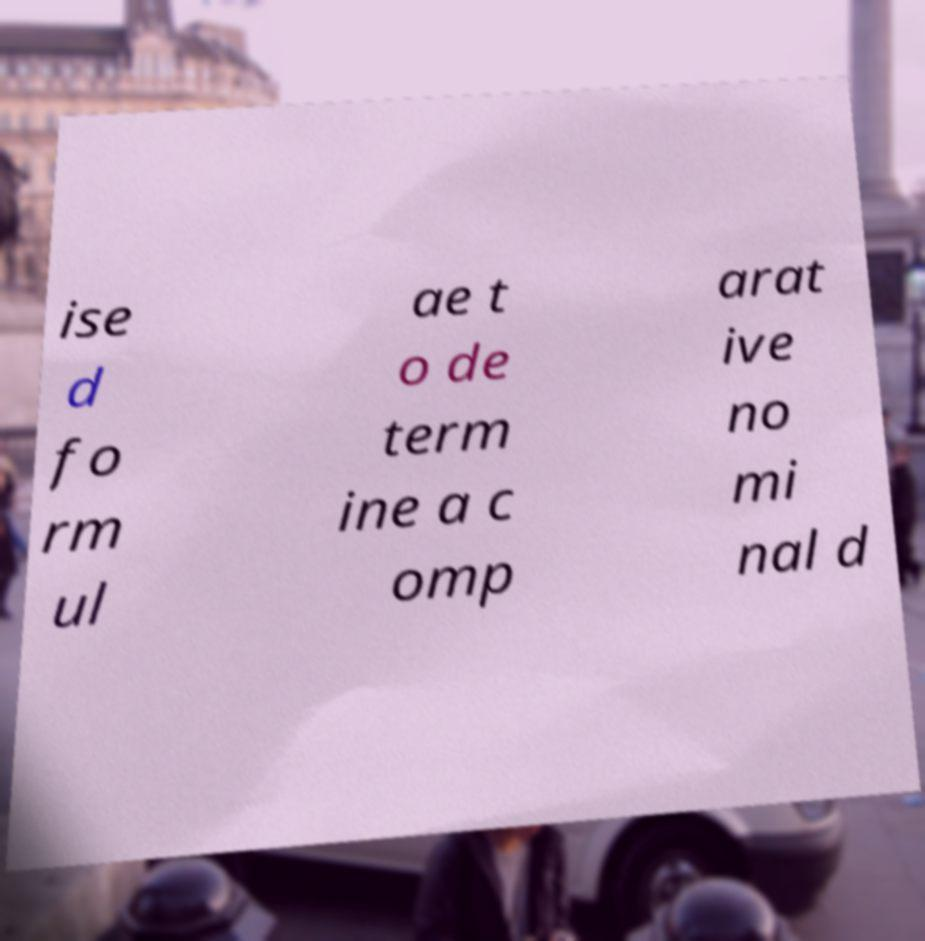Can you read and provide the text displayed in the image?This photo seems to have some interesting text. Can you extract and type it out for me? ise d fo rm ul ae t o de term ine a c omp arat ive no mi nal d 